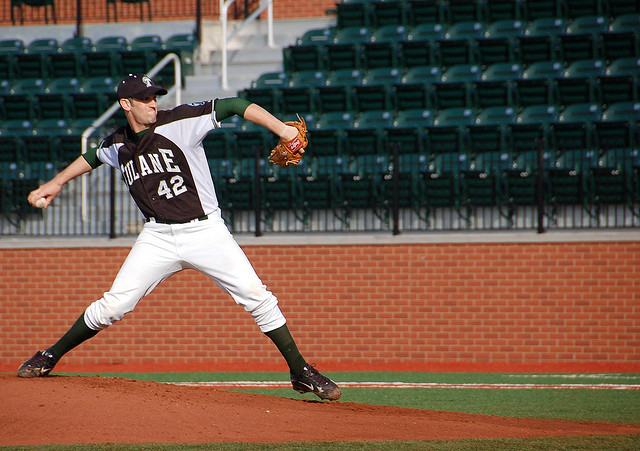Please transcribe the text information in this image. 42 T 